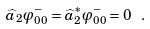<formula> <loc_0><loc_0><loc_500><loc_500>\widehat { a } _ { 2 } \varphi ^ { - } _ { 0 0 } = \widehat { a } ^ { * } _ { 2 } \varphi ^ { - } _ { 0 0 } = 0 \ .</formula> 